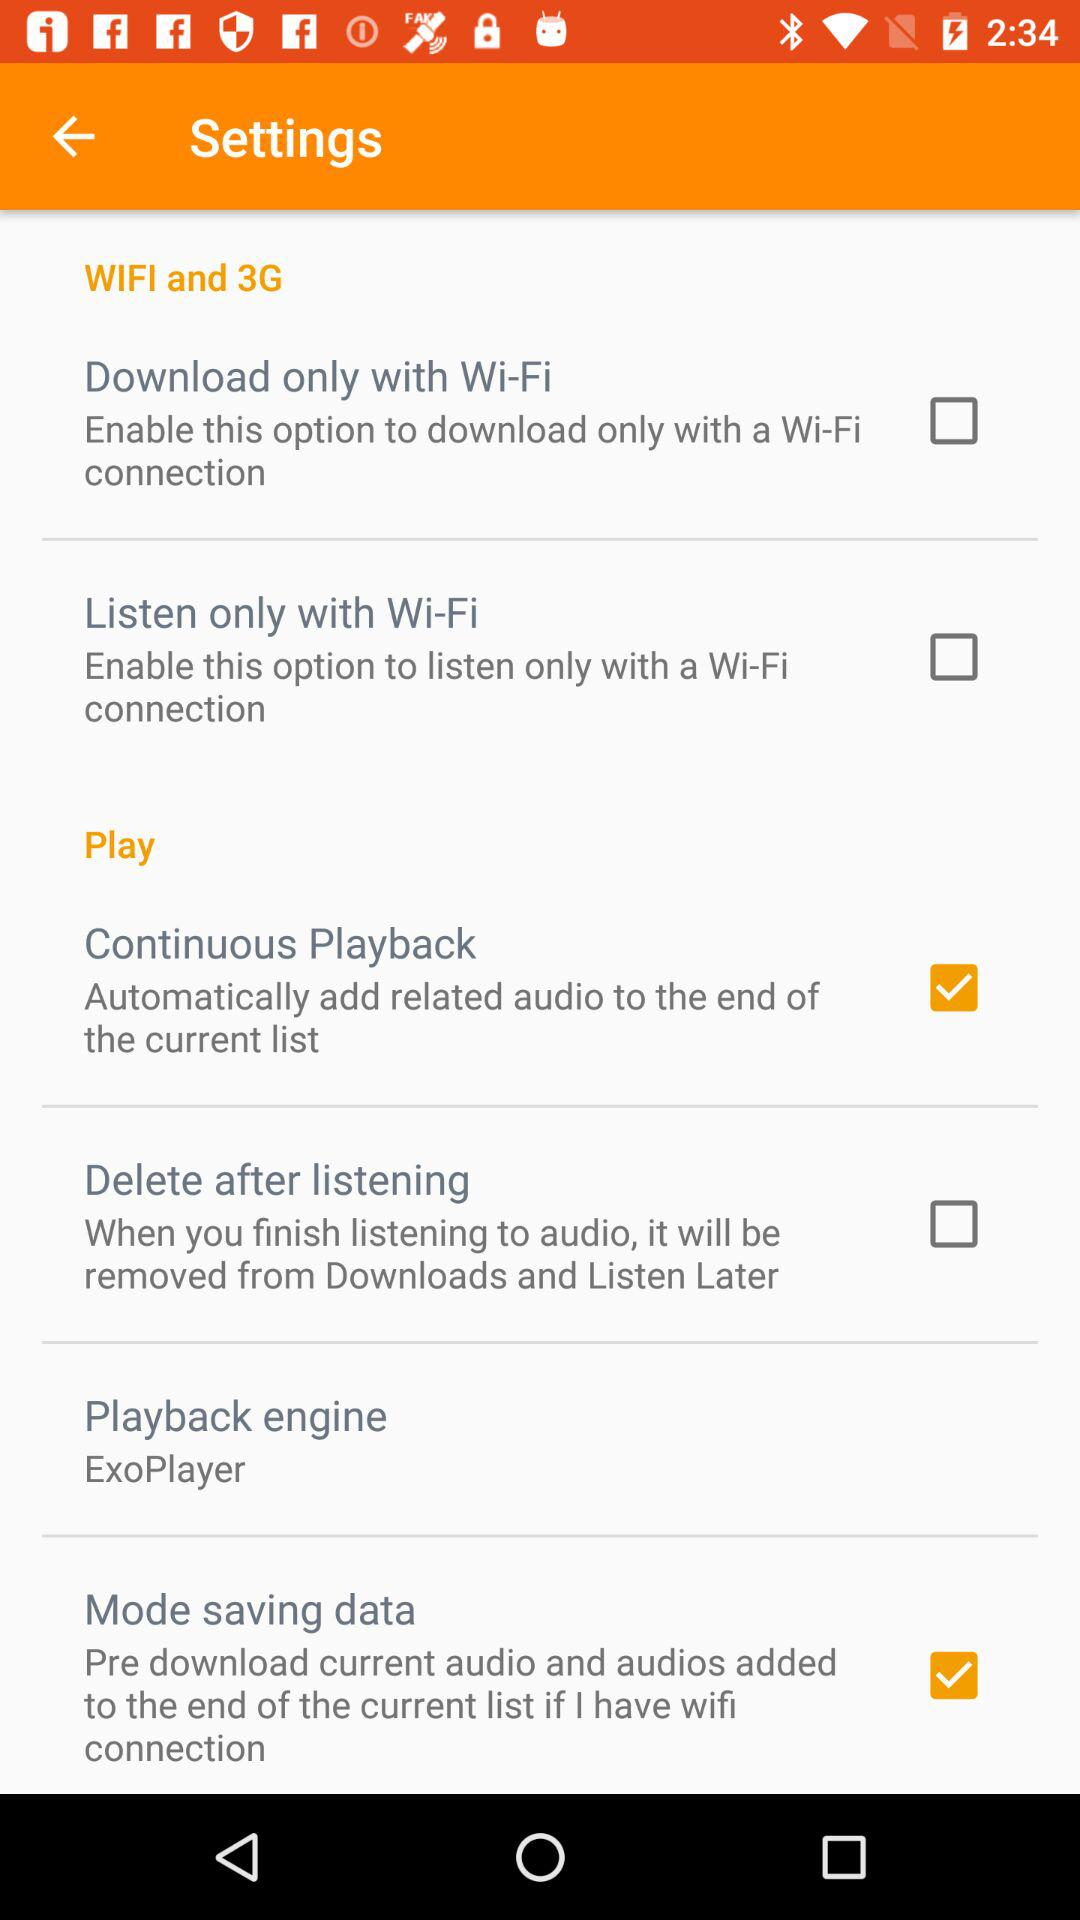Which option was checked? The checked options were "Continuous Playback" and "Mode saving data". 